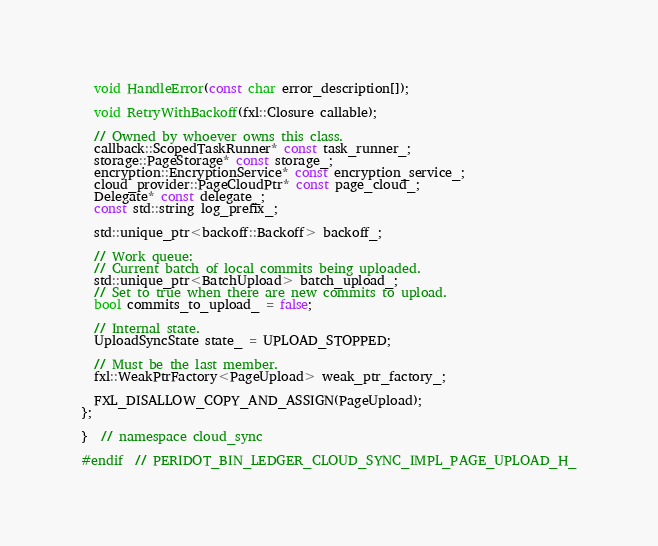Convert code to text. <code><loc_0><loc_0><loc_500><loc_500><_C_>  void HandleError(const char error_description[]);

  void RetryWithBackoff(fxl::Closure callable);

  // Owned by whoever owns this class.
  callback::ScopedTaskRunner* const task_runner_;
  storage::PageStorage* const storage_;
  encryption::EncryptionService* const encryption_service_;
  cloud_provider::PageCloudPtr* const page_cloud_;
  Delegate* const delegate_;
  const std::string log_prefix_;

  std::unique_ptr<backoff::Backoff> backoff_;

  // Work queue:
  // Current batch of local commits being uploaded.
  std::unique_ptr<BatchUpload> batch_upload_;
  // Set to true when there are new commits to upload.
  bool commits_to_upload_ = false;

  // Internal state.
  UploadSyncState state_ = UPLOAD_STOPPED;

  // Must be the last member.
  fxl::WeakPtrFactory<PageUpload> weak_ptr_factory_;

  FXL_DISALLOW_COPY_AND_ASSIGN(PageUpload);
};

}  // namespace cloud_sync

#endif  // PERIDOT_BIN_LEDGER_CLOUD_SYNC_IMPL_PAGE_UPLOAD_H_
</code> 